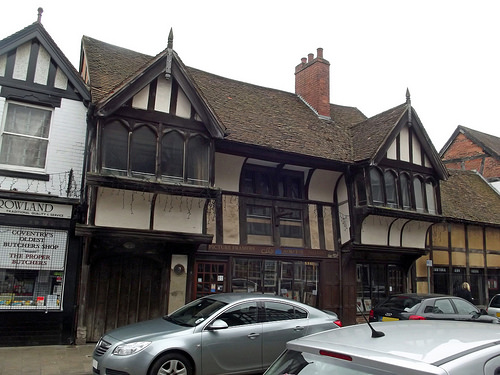<image>
Can you confirm if the building is behind the car? Yes. From this viewpoint, the building is positioned behind the car, with the car partially or fully occluding the building. 